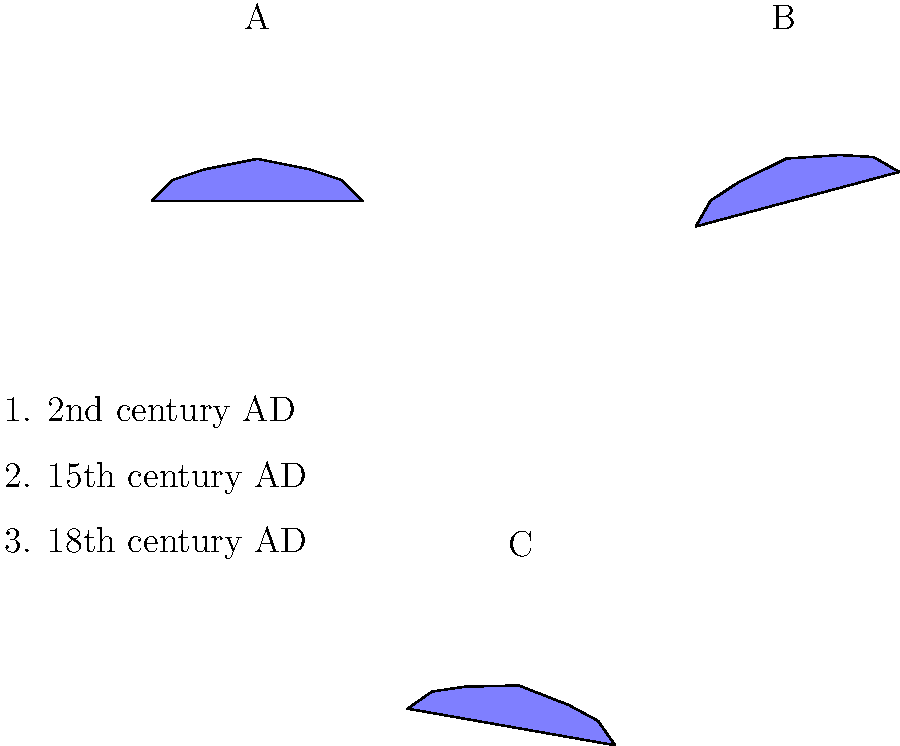Match the world maps A, B, and C to their corresponding time periods (1, 2, and 3) based on their geographical accuracy and distortion. Which map-time period pairing is correct? To answer this question, we need to analyze the distortion and accuracy of each map in relation to historical cartography:

1. Map A shows no rotation or significant distortion. This level of accuracy was not achievable in ancient times, making it the most recent map.

2. Map B shows a significant clockwise rotation. This type of distortion was common in medieval and early Renaissance maps due to limited geographical knowledge and navigation techniques.

3. Map C shows a slight counterclockwise rotation. This represents an intermediate level of accuracy between the other two maps.

Considering the historical development of cartography:

1. 2nd century AD: Ptolemy's world map, while groundbreaking, had significant distortions due to limited exploration. This best matches Map B.

2. 15th century AD: Maps improved with the Age of Exploration, but still contained inaccuracies. Map C best represents this period.

3. 18th century AD: Cartography became much more accurate with advanced surveying and navigation techniques. Map A, with its lack of distortion, best represents this era.

Therefore, the correct pairing is:
A - 3 (18th century AD)
B - 1 (2nd century AD)
C - 2 (15th century AD)
Answer: B-1, C-2, A-3 